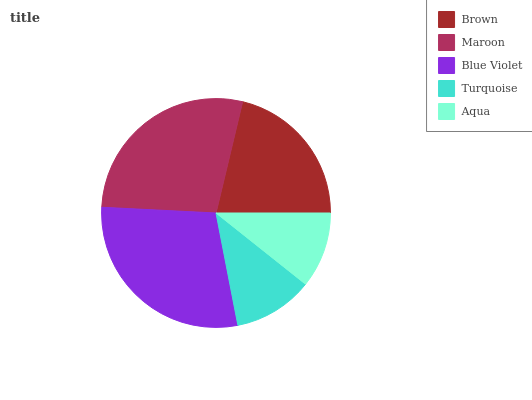Is Aqua the minimum?
Answer yes or no. Yes. Is Blue Violet the maximum?
Answer yes or no. Yes. Is Maroon the minimum?
Answer yes or no. No. Is Maroon the maximum?
Answer yes or no. No. Is Maroon greater than Brown?
Answer yes or no. Yes. Is Brown less than Maroon?
Answer yes or no. Yes. Is Brown greater than Maroon?
Answer yes or no. No. Is Maroon less than Brown?
Answer yes or no. No. Is Brown the high median?
Answer yes or no. Yes. Is Brown the low median?
Answer yes or no. Yes. Is Maroon the high median?
Answer yes or no. No. Is Maroon the low median?
Answer yes or no. No. 